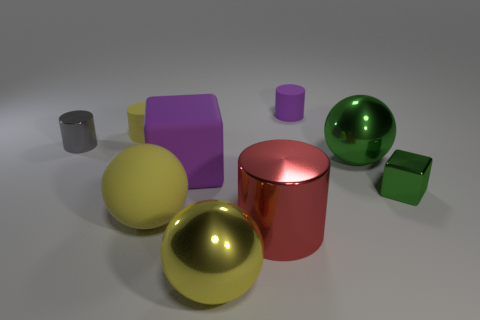Subtract all cylinders. How many objects are left? 5 Add 2 green shiny objects. How many green shiny objects exist? 4 Subtract 0 red blocks. How many objects are left? 9 Subtract all large matte objects. Subtract all small blue metal blocks. How many objects are left? 7 Add 6 tiny matte objects. How many tiny matte objects are left? 8 